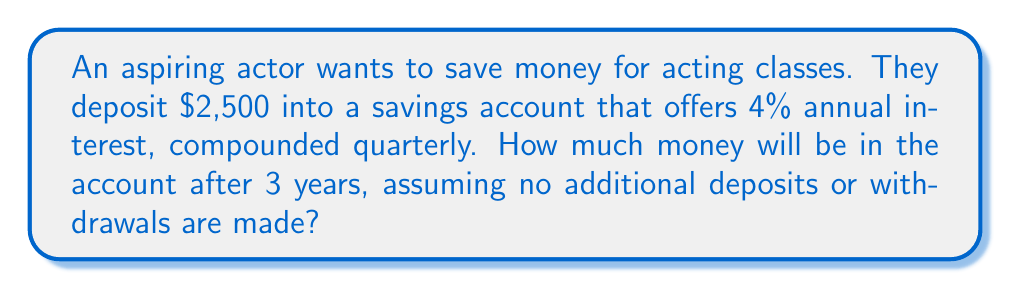Help me with this question. To solve this problem, we'll use the compound interest formula:

$$ A = P(1 + \frac{r}{n})^{nt} $$

Where:
$A$ = final amount
$P$ = principal (initial investment)
$r$ = annual interest rate (as a decimal)
$n$ = number of times interest is compounded per year
$t$ = number of years

Given:
$P = 2500$
$r = 0.04$ (4% expressed as a decimal)
$n = 4$ (compounded quarterly, so 4 times per year)
$t = 3$ years

Let's substitute these values into the formula:

$$ A = 2500(1 + \frac{0.04}{4})^{4 \times 3} $$

$$ A = 2500(1 + 0.01)^{12} $$

$$ A = 2500(1.01)^{12} $$

Now, let's calculate:

$$ A = 2500 \times 1.1268250 $$

$$ A = 2817.06 $$

Rounding to the nearest cent gives us $2,817.06.
Answer: $2,817.06 